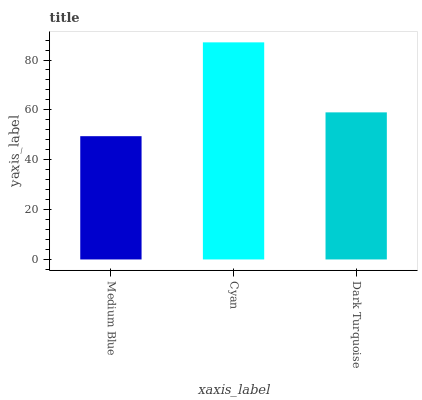Is Dark Turquoise the minimum?
Answer yes or no. No. Is Dark Turquoise the maximum?
Answer yes or no. No. Is Cyan greater than Dark Turquoise?
Answer yes or no. Yes. Is Dark Turquoise less than Cyan?
Answer yes or no. Yes. Is Dark Turquoise greater than Cyan?
Answer yes or no. No. Is Cyan less than Dark Turquoise?
Answer yes or no. No. Is Dark Turquoise the high median?
Answer yes or no. Yes. Is Dark Turquoise the low median?
Answer yes or no. Yes. Is Cyan the high median?
Answer yes or no. No. Is Medium Blue the low median?
Answer yes or no. No. 